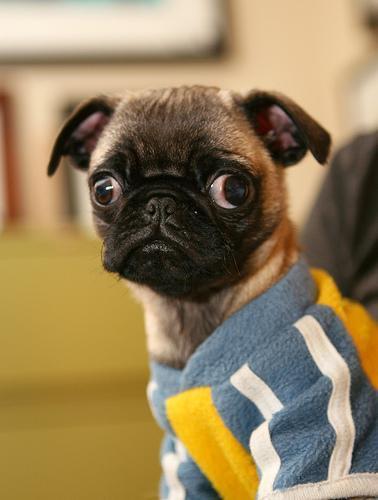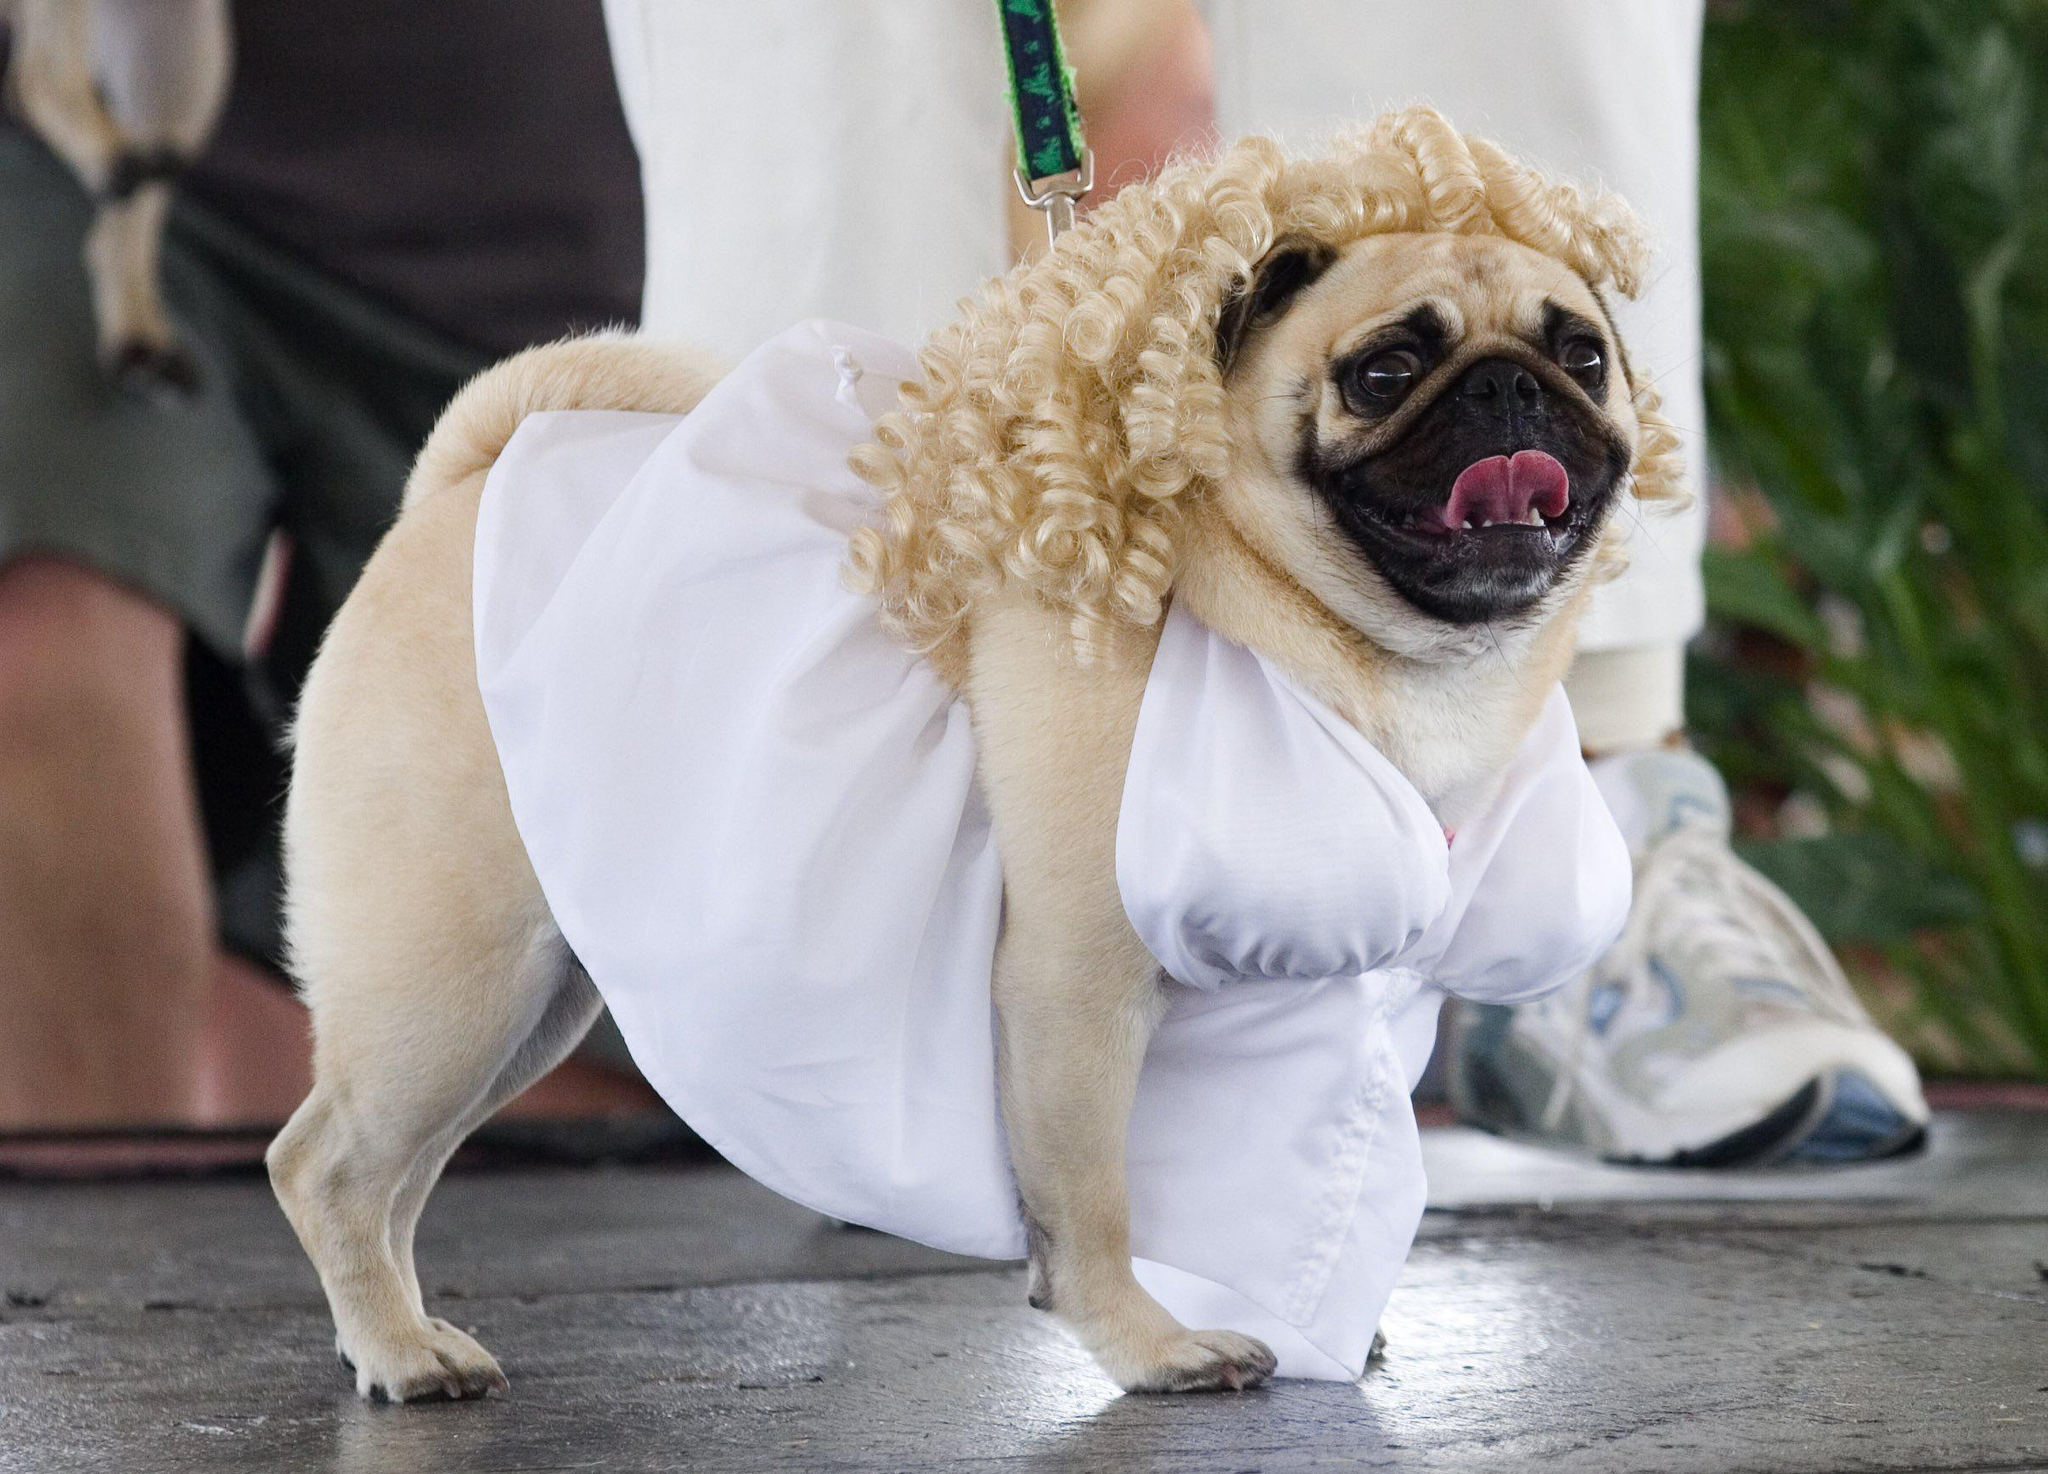The first image is the image on the left, the second image is the image on the right. Analyze the images presented: Is the assertion "Each image contains one pug wearing an outfit, including the letfthand dog wearing a grayish and yellow outift, and the righthand dog in formal human-like attire." valid? Answer yes or no. Yes. The first image is the image on the left, the second image is the image on the right. For the images displayed, is the sentence "There is at least three dogs." factually correct? Answer yes or no. No. 